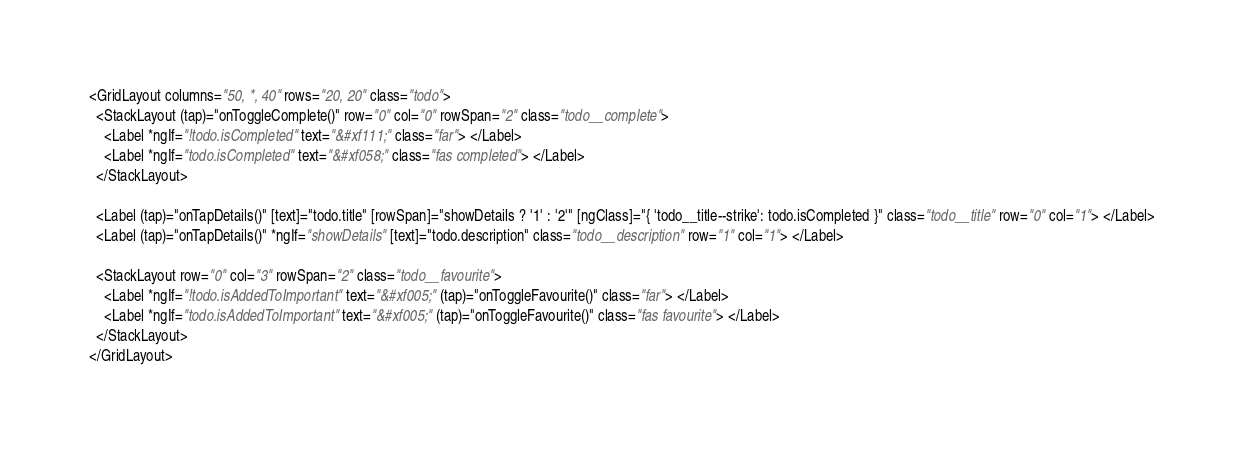Convert code to text. <code><loc_0><loc_0><loc_500><loc_500><_HTML_><GridLayout columns="50, *, 40" rows="20, 20" class="todo">
  <StackLayout (tap)="onToggleComplete()" row="0" col="0" rowSpan="2" class="todo__complete">
    <Label *ngIf="!todo.isCompleted" text="&#xf111;" class="far"> </Label>
    <Label *ngIf="todo.isCompleted" text="&#xf058;" class="fas completed"> </Label>
  </StackLayout>

  <Label (tap)="onTapDetails()" [text]="todo.title" [rowSpan]="showDetails ? '1' : '2'" [ngClass]="{ 'todo__title--strike': todo.isCompleted }" class="todo__title" row="0" col="1"> </Label>
  <Label (tap)="onTapDetails()" *ngIf="showDetails" [text]="todo.description" class="todo__description" row="1" col="1"> </Label>

  <StackLayout row="0" col="3" rowSpan="2" class="todo__favourite">
    <Label *ngIf="!todo.isAddedToImportant" text="&#xf005;" (tap)="onToggleFavourite()" class="far"> </Label>
    <Label *ngIf="todo.isAddedToImportant" text="&#xf005;" (tap)="onToggleFavourite()" class="fas favourite"> </Label>
  </StackLayout>
</GridLayout>
</code> 